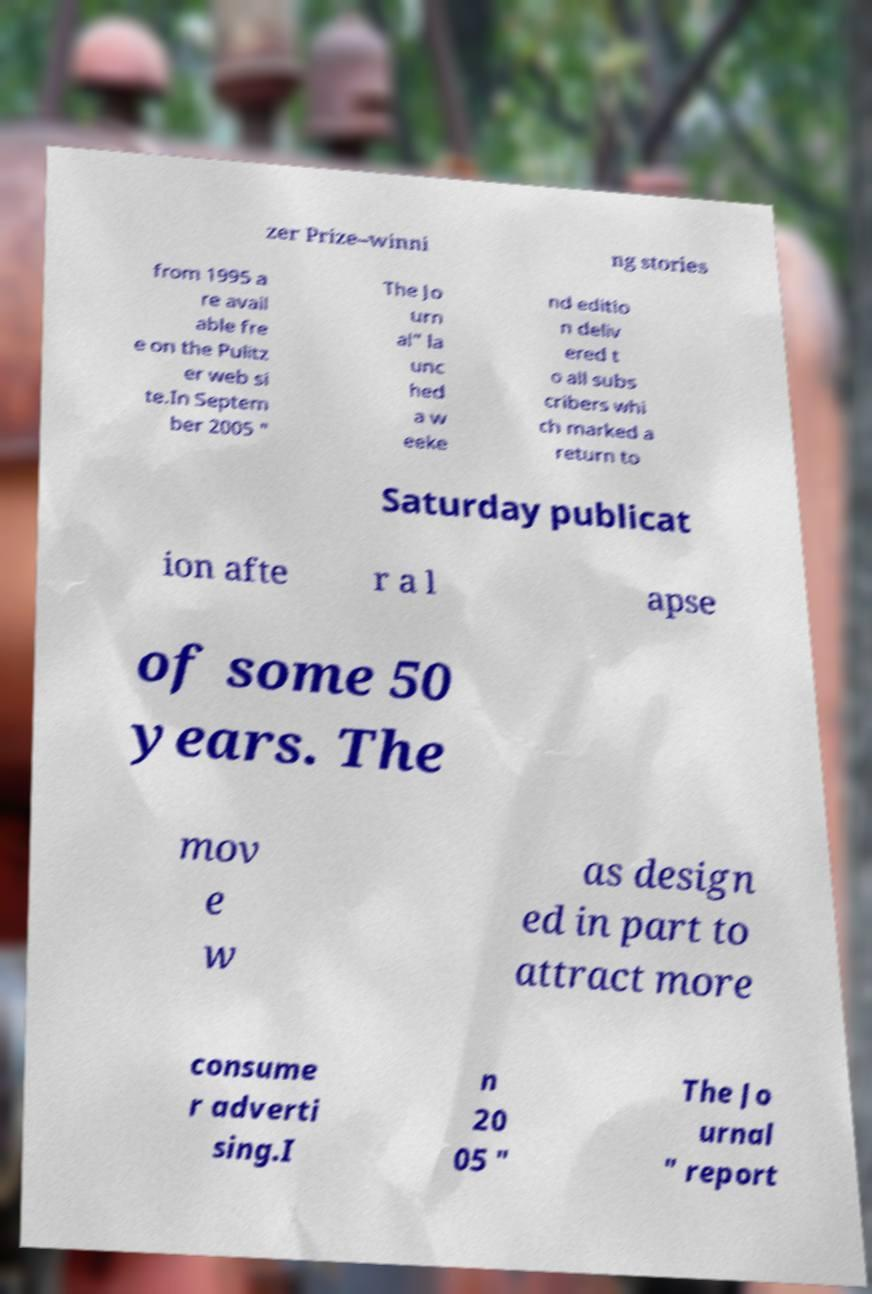Can you read and provide the text displayed in the image?This photo seems to have some interesting text. Can you extract and type it out for me? zer Prize–winni ng stories from 1995 a re avail able fre e on the Pulitz er web si te.In Septem ber 2005 " The Jo urn al" la unc hed a w eeke nd editio n deliv ered t o all subs cribers whi ch marked a return to Saturday publicat ion afte r a l apse of some 50 years. The mov e w as design ed in part to attract more consume r adverti sing.I n 20 05 " The Jo urnal " report 